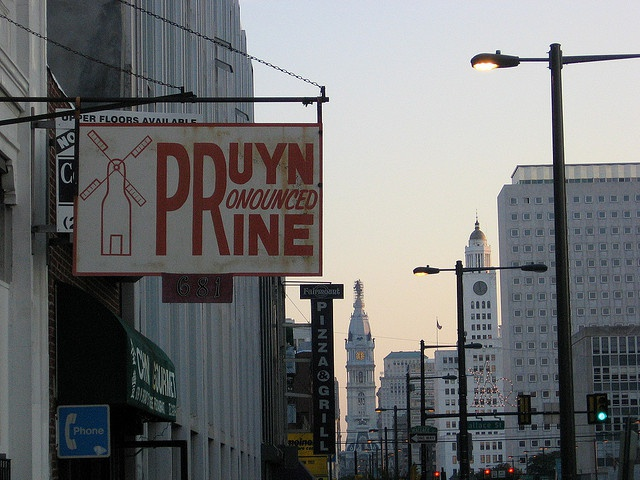Describe the objects in this image and their specific colors. I can see traffic light in gray, black, teal, and lightblue tones, traffic light in gray and black tones, traffic light in black and gray tones, traffic light in gray, black, red, and maroon tones, and traffic light in gray, black, maroon, red, and brown tones in this image. 